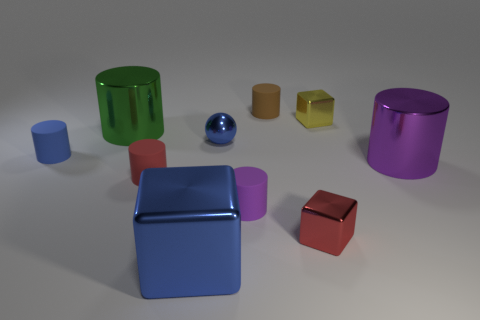Subtract 3 cylinders. How many cylinders are left? 3 Subtract all brown matte cylinders. How many cylinders are left? 5 Subtract all red cylinders. How many cylinders are left? 5 Subtract all gray cylinders. Subtract all gray spheres. How many cylinders are left? 6 Subtract all cylinders. How many objects are left? 4 Add 4 yellow shiny blocks. How many yellow shiny blocks are left? 5 Add 7 cyan rubber things. How many cyan rubber things exist? 7 Subtract 1 red cylinders. How many objects are left? 9 Subtract all cyan blocks. Subtract all large objects. How many objects are left? 7 